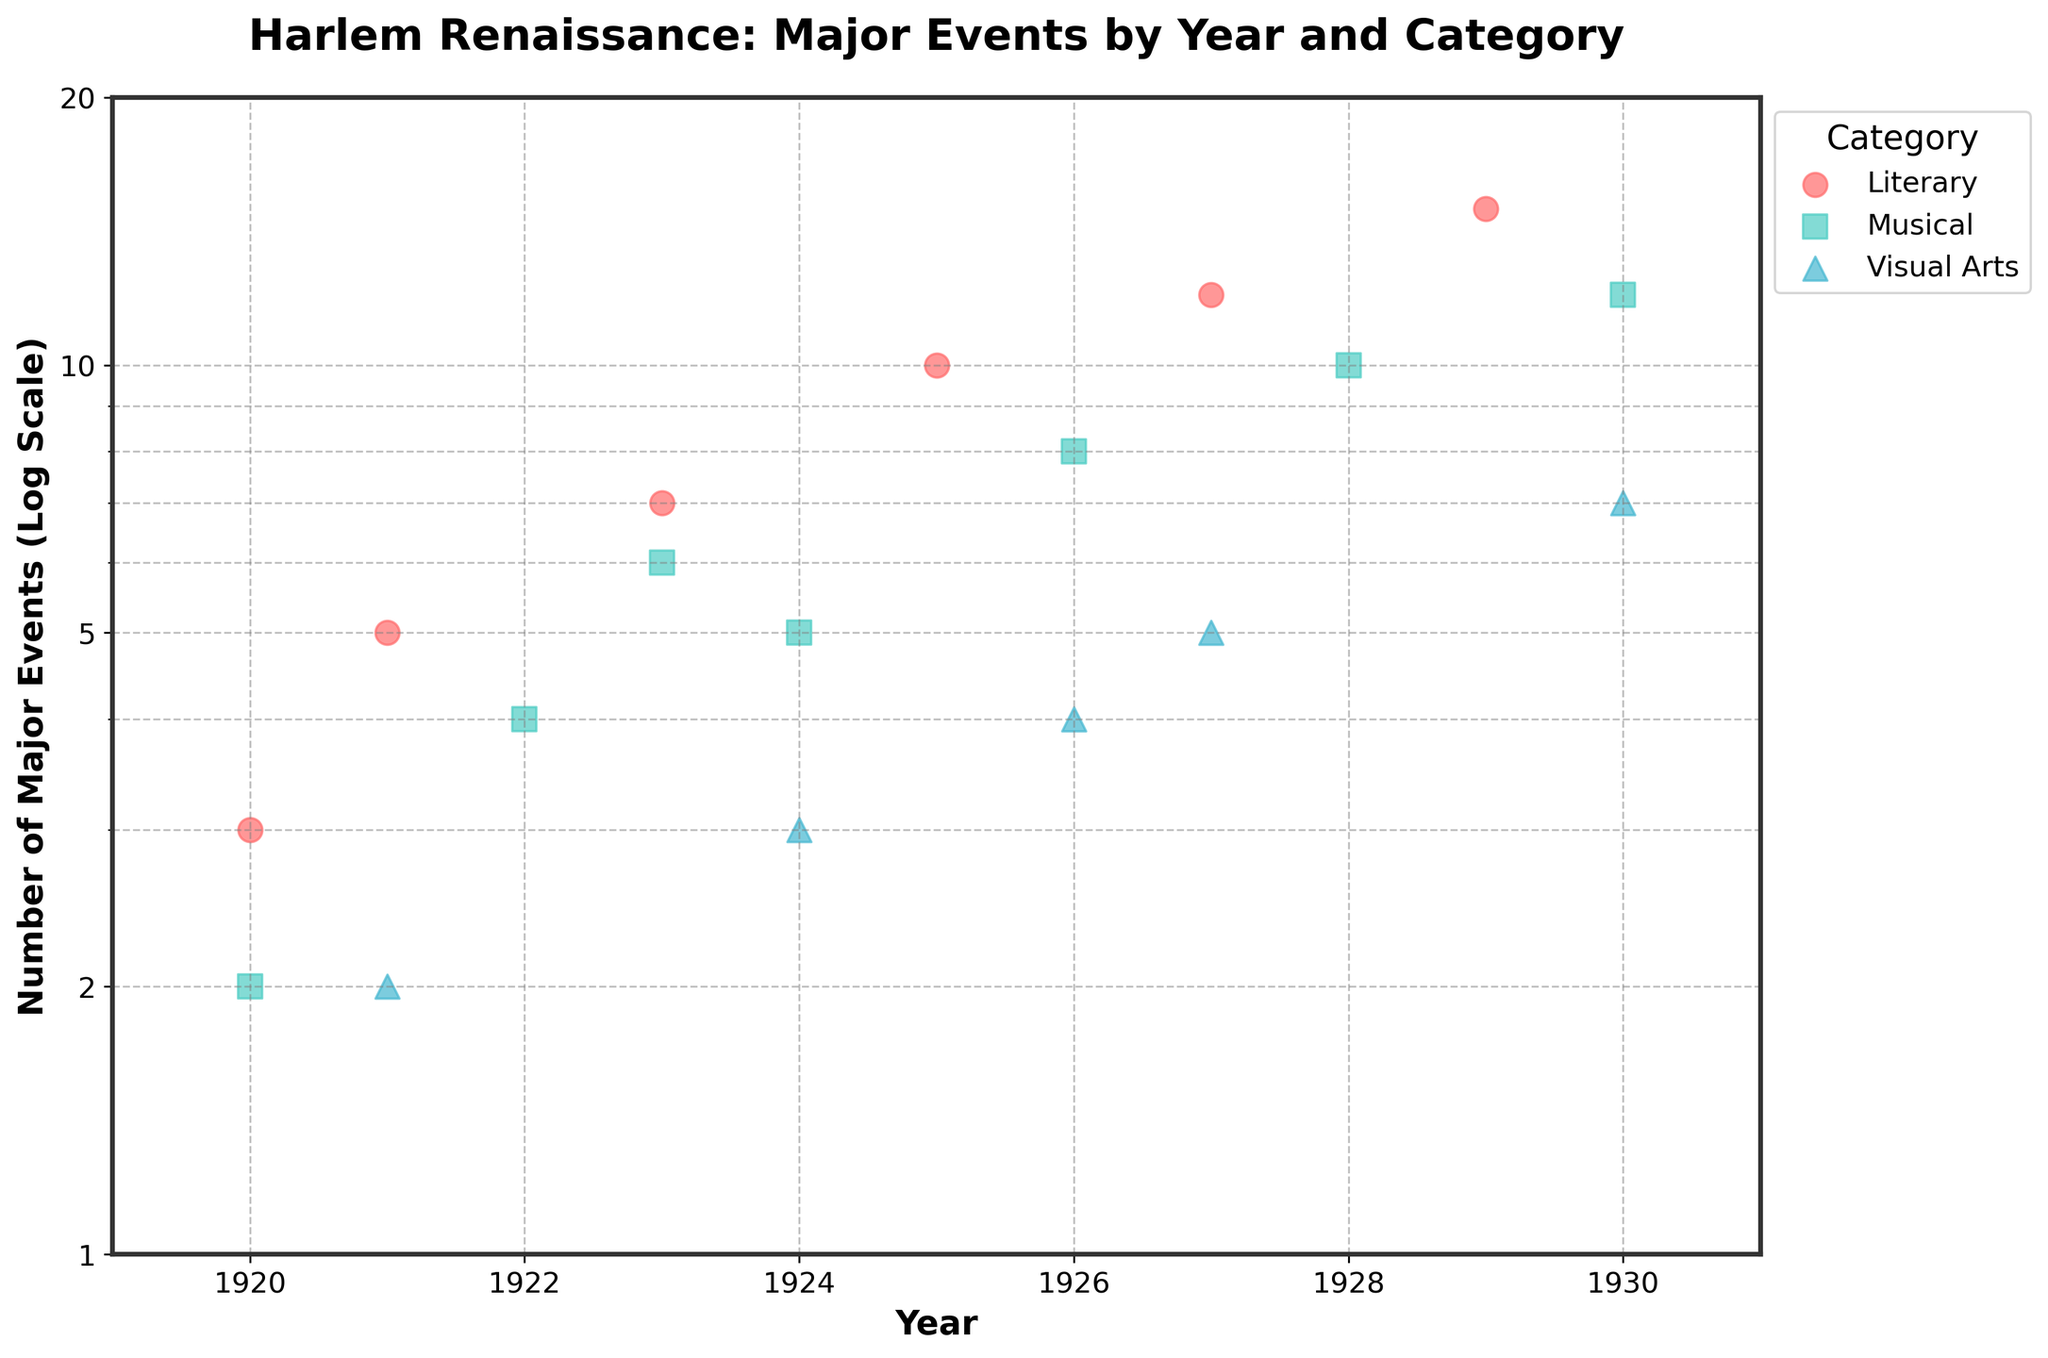What is the title of the scatter plot? Look at the top of the plot where the title is prominently displayed in bold letters.
Answer: Harlem Renaissance: Major Events by Year and Category What are the categories represented in the scatter plot? Identify the different categories from the legend on the right side of the plot.
Answer: Literary, Musical, Visual Arts What type of scale is used for the y-axis? Examine the label on the y-axis that indicates the scaling type applied.
Answer: Logarithmic scale In which year did the 'Musical' category have its highest number of major events? Look for the highest point plotted for the 'Musical' category (designated by a specific marker and color) along the y-axis corresponding to each year.
Answer: 1930 How many major literary events were held in 1927? Locate the points for the 'Literary' category and find the value that aligns with the year 1927 on the x-axis and note the corresponding y-axis value.
Answer: 12 Which category had the least number of major events in 1924, and how many were they? Look at the year 1924 on the x-axis and compare the y-axis values of each category to find the smallest one.
Answer: Visual Arts, 3 How does the number of major events in the 'Visual Arts' category change between 1926 and 1930? Compare the y-axis values for the 'Visual Arts' category for the years 1926 and 1930.
Answer: From 4 in 1926 to 7 in 1930 What is the range of the number of major events detected on the plot (y-axis)? Identify the minimum and maximum values represented on the y-axis from the scatter plot.
Answer: 1 to 20 Which categories saw an increase in the number of major events from 1925 to 1926? Compare the points for each category in 1925 and 1926 to see whether the number of events increased.
Answer: Visual Arts, Musical What is the total number of major 'Musical' events from 1920 to 1930? Sum the y-values corresponding to the 'Musical' category for each year from 1920 to 1930.
Answer: 47 